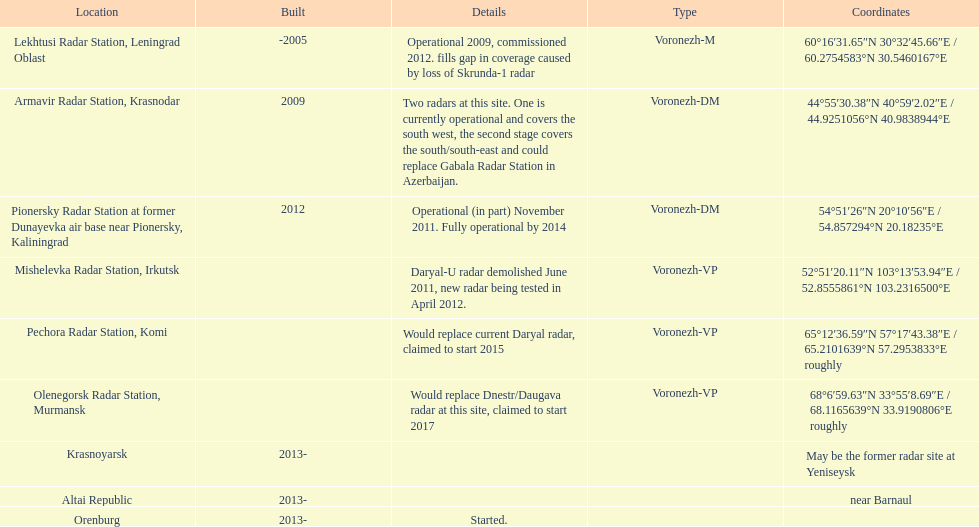How many locations are there in total? 9. 